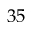<formula> <loc_0><loc_0><loc_500><loc_500>3 5</formula> 